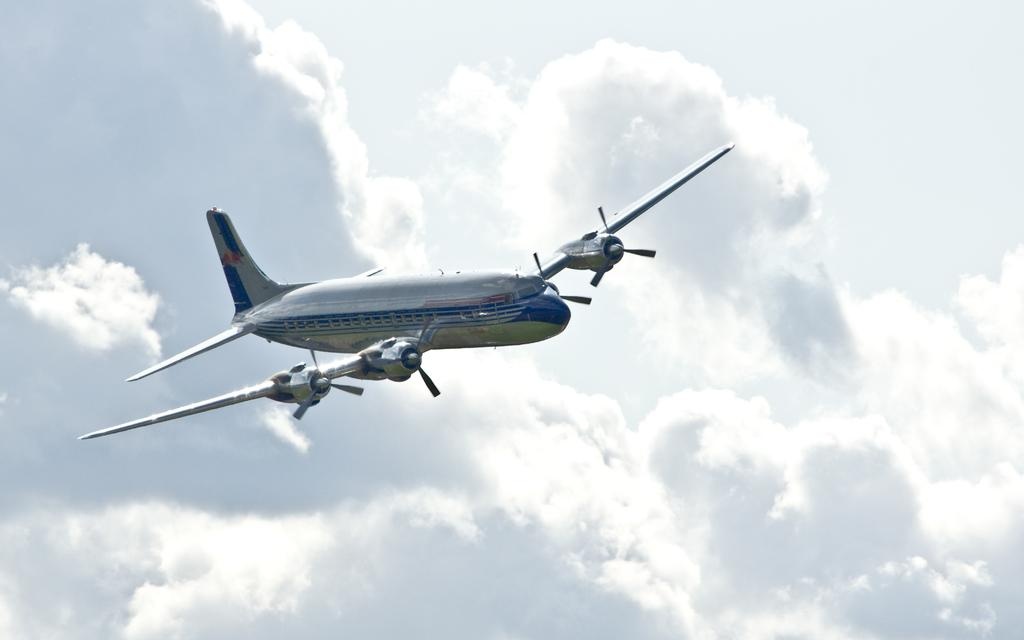What is the main subject of the image? The main subject of the image is an airplane. Where is the airplane located in the image? The airplane is in the air. What can be seen in the background of the image? The sky is visible in the background of the image. How would you describe the sky in the image? The sky appears to be cloudy. Where is the drain located in the image? There is no drain present in the image. What type of spoon can be seen in the image? There is no spoon present in the image. 